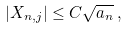<formula> <loc_0><loc_0><loc_500><loc_500>| X _ { n , j } | \leq C \sqrt { a _ { n } } \, ,</formula> 